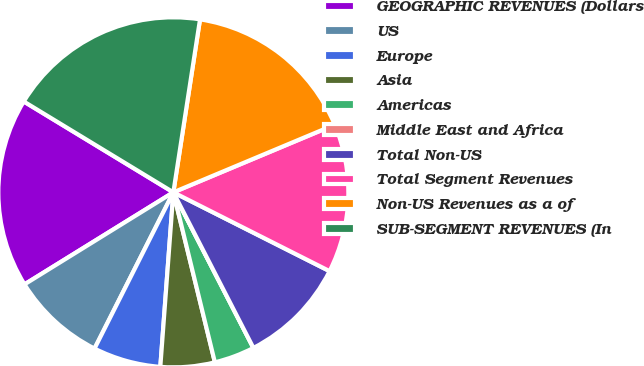Convert chart. <chart><loc_0><loc_0><loc_500><loc_500><pie_chart><fcel>GEOGRAPHIC REVENUES (Dollars<fcel>US<fcel>Europe<fcel>Asia<fcel>Americas<fcel>Middle East and Africa<fcel>Total Non-US<fcel>Total Segment Revenues<fcel>Non-US Revenues as a of<fcel>SUB-SEGMENT REVENUES (In<nl><fcel>17.5%<fcel>8.75%<fcel>6.25%<fcel>5.0%<fcel>3.75%<fcel>0.0%<fcel>10.0%<fcel>13.75%<fcel>16.25%<fcel>18.75%<nl></chart> 